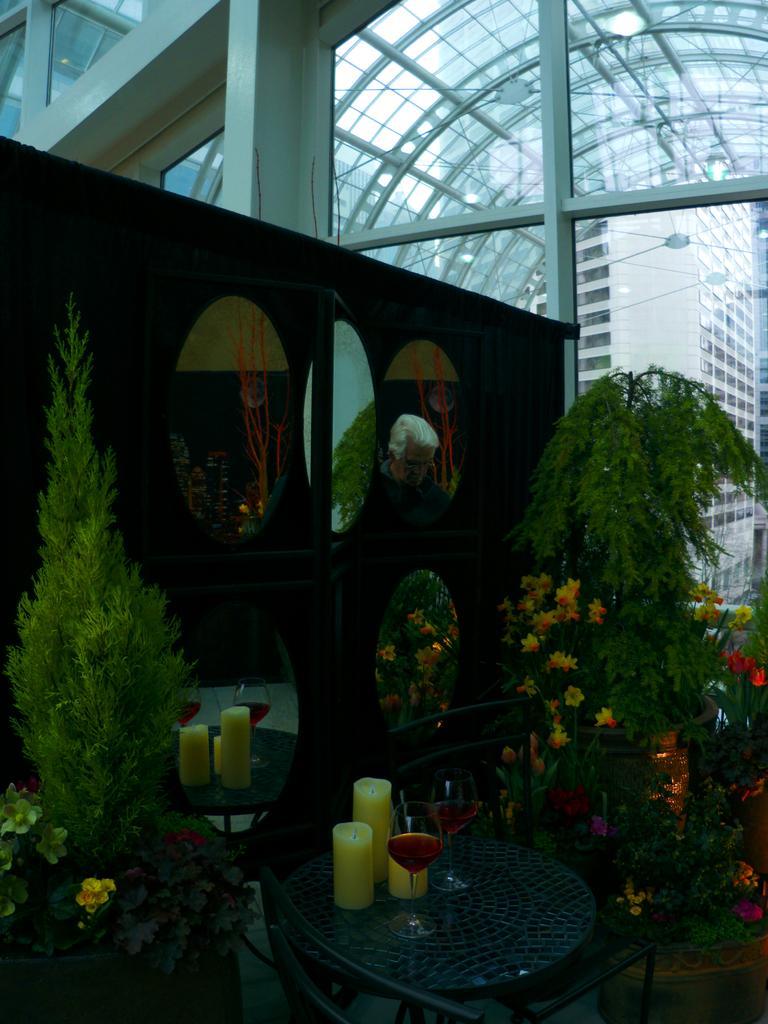Describe this image in one or two sentences. In the foreground of the image we can see the group of candles and glasses placed on a table. To the left side we can see a plant. In the background, we can see group of, mirrors placed in a cupboard and a building and some flowers on a plant. 